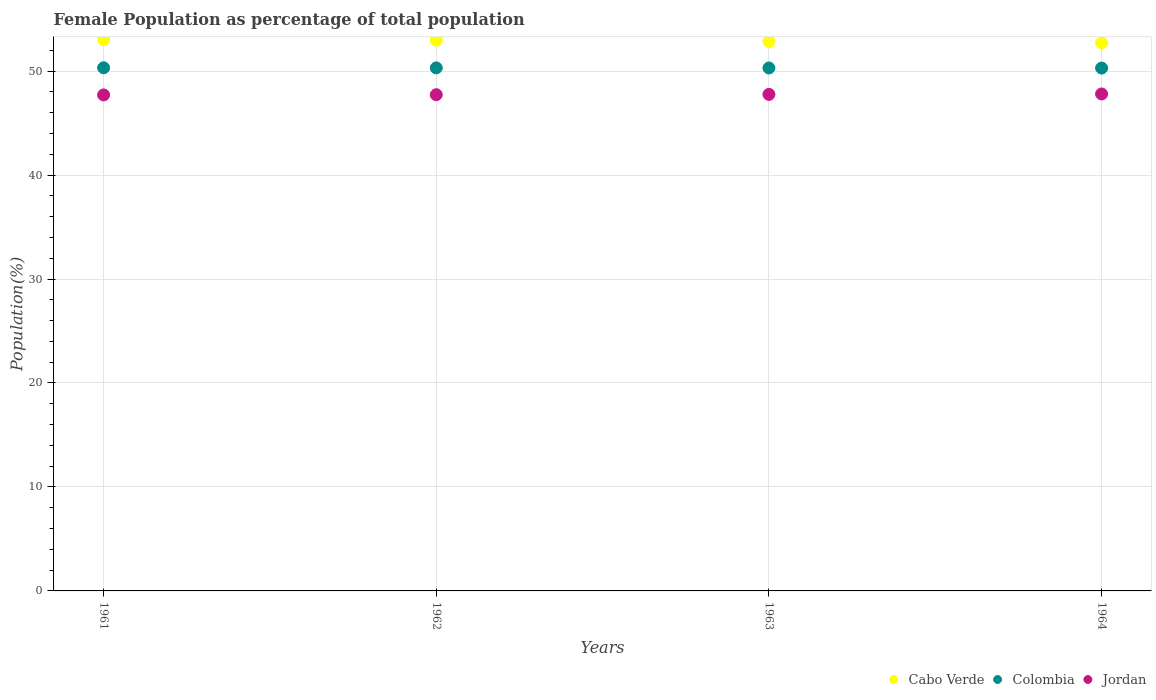How many different coloured dotlines are there?
Your answer should be very brief. 3. What is the female population in in Jordan in 1962?
Your answer should be very brief. 47.73. Across all years, what is the maximum female population in in Colombia?
Your answer should be compact. 50.32. Across all years, what is the minimum female population in in Jordan?
Give a very brief answer. 47.71. In which year was the female population in in Jordan maximum?
Ensure brevity in your answer.  1964. In which year was the female population in in Cabo Verde minimum?
Provide a short and direct response. 1964. What is the total female population in in Colombia in the graph?
Offer a very short reply. 201.22. What is the difference between the female population in in Colombia in 1963 and that in 1964?
Your answer should be very brief. 0.01. What is the difference between the female population in in Cabo Verde in 1962 and the female population in in Jordan in 1961?
Give a very brief answer. 5.26. What is the average female population in in Jordan per year?
Provide a short and direct response. 47.75. In the year 1963, what is the difference between the female population in in Jordan and female population in in Colombia?
Make the answer very short. -2.54. In how many years, is the female population in in Jordan greater than 38 %?
Make the answer very short. 4. What is the ratio of the female population in in Jordan in 1963 to that in 1964?
Your response must be concise. 1. What is the difference between the highest and the second highest female population in in Cabo Verde?
Your answer should be very brief. 0.08. What is the difference between the highest and the lowest female population in in Jordan?
Offer a very short reply. 0.09. In how many years, is the female population in in Jordan greater than the average female population in in Jordan taken over all years?
Your answer should be very brief. 2. Is the sum of the female population in in Cabo Verde in 1961 and 1964 greater than the maximum female population in in Colombia across all years?
Your response must be concise. Yes. Is it the case that in every year, the sum of the female population in in Cabo Verde and female population in in Colombia  is greater than the female population in in Jordan?
Provide a short and direct response. Yes. Does the female population in in Colombia monotonically increase over the years?
Offer a terse response. No. Is the female population in in Jordan strictly greater than the female population in in Cabo Verde over the years?
Offer a terse response. No. How many dotlines are there?
Provide a short and direct response. 3. How many years are there in the graph?
Make the answer very short. 4. Are the values on the major ticks of Y-axis written in scientific E-notation?
Provide a succinct answer. No. Does the graph contain any zero values?
Keep it short and to the point. No. How many legend labels are there?
Offer a very short reply. 3. How are the legend labels stacked?
Make the answer very short. Horizontal. What is the title of the graph?
Your answer should be compact. Female Population as percentage of total population. What is the label or title of the X-axis?
Ensure brevity in your answer.  Years. What is the label or title of the Y-axis?
Give a very brief answer. Population(%). What is the Population(%) in Cabo Verde in 1961?
Your answer should be compact. 53.05. What is the Population(%) of Colombia in 1961?
Give a very brief answer. 50.32. What is the Population(%) of Jordan in 1961?
Your answer should be compact. 47.71. What is the Population(%) of Cabo Verde in 1962?
Ensure brevity in your answer.  52.97. What is the Population(%) of Colombia in 1962?
Your response must be concise. 50.31. What is the Population(%) in Jordan in 1962?
Offer a very short reply. 47.73. What is the Population(%) of Cabo Verde in 1963?
Ensure brevity in your answer.  52.85. What is the Population(%) of Colombia in 1963?
Ensure brevity in your answer.  50.3. What is the Population(%) of Jordan in 1963?
Give a very brief answer. 47.76. What is the Population(%) of Cabo Verde in 1964?
Provide a succinct answer. 52.72. What is the Population(%) of Colombia in 1964?
Your answer should be compact. 50.29. What is the Population(%) of Jordan in 1964?
Make the answer very short. 47.8. Across all years, what is the maximum Population(%) in Cabo Verde?
Your answer should be compact. 53.05. Across all years, what is the maximum Population(%) of Colombia?
Give a very brief answer. 50.32. Across all years, what is the maximum Population(%) in Jordan?
Your response must be concise. 47.8. Across all years, what is the minimum Population(%) of Cabo Verde?
Ensure brevity in your answer.  52.72. Across all years, what is the minimum Population(%) of Colombia?
Offer a very short reply. 50.29. Across all years, what is the minimum Population(%) of Jordan?
Ensure brevity in your answer.  47.71. What is the total Population(%) in Cabo Verde in the graph?
Your answer should be very brief. 211.6. What is the total Population(%) in Colombia in the graph?
Your response must be concise. 201.22. What is the total Population(%) in Jordan in the graph?
Provide a succinct answer. 191.01. What is the difference between the Population(%) of Cabo Verde in 1961 and that in 1962?
Keep it short and to the point. 0.08. What is the difference between the Population(%) in Colombia in 1961 and that in 1962?
Your response must be concise. 0.01. What is the difference between the Population(%) of Jordan in 1961 and that in 1962?
Offer a very short reply. -0.02. What is the difference between the Population(%) of Cabo Verde in 1961 and that in 1963?
Offer a very short reply. 0.2. What is the difference between the Population(%) in Colombia in 1961 and that in 1963?
Provide a short and direct response. 0.02. What is the difference between the Population(%) in Jordan in 1961 and that in 1963?
Your response must be concise. -0.05. What is the difference between the Population(%) of Cabo Verde in 1961 and that in 1964?
Your answer should be compact. 0.33. What is the difference between the Population(%) in Colombia in 1961 and that in 1964?
Keep it short and to the point. 0.03. What is the difference between the Population(%) of Jordan in 1961 and that in 1964?
Keep it short and to the point. -0.09. What is the difference between the Population(%) of Cabo Verde in 1962 and that in 1963?
Provide a short and direct response. 0.12. What is the difference between the Population(%) in Colombia in 1962 and that in 1963?
Your answer should be very brief. 0.01. What is the difference between the Population(%) in Jordan in 1962 and that in 1963?
Offer a very short reply. -0.03. What is the difference between the Population(%) of Cabo Verde in 1962 and that in 1964?
Provide a succinct answer. 0.26. What is the difference between the Population(%) of Colombia in 1962 and that in 1964?
Make the answer very short. 0.02. What is the difference between the Population(%) of Jordan in 1962 and that in 1964?
Give a very brief answer. -0.07. What is the difference between the Population(%) in Cabo Verde in 1963 and that in 1964?
Make the answer very short. 0.13. What is the difference between the Population(%) in Colombia in 1963 and that in 1964?
Ensure brevity in your answer.  0.01. What is the difference between the Population(%) of Jordan in 1963 and that in 1964?
Offer a terse response. -0.04. What is the difference between the Population(%) in Cabo Verde in 1961 and the Population(%) in Colombia in 1962?
Your answer should be very brief. 2.74. What is the difference between the Population(%) in Cabo Verde in 1961 and the Population(%) in Jordan in 1962?
Your answer should be very brief. 5.32. What is the difference between the Population(%) in Colombia in 1961 and the Population(%) in Jordan in 1962?
Your response must be concise. 2.59. What is the difference between the Population(%) in Cabo Verde in 1961 and the Population(%) in Colombia in 1963?
Your answer should be compact. 2.75. What is the difference between the Population(%) in Cabo Verde in 1961 and the Population(%) in Jordan in 1963?
Make the answer very short. 5.29. What is the difference between the Population(%) of Colombia in 1961 and the Population(%) of Jordan in 1963?
Offer a terse response. 2.56. What is the difference between the Population(%) in Cabo Verde in 1961 and the Population(%) in Colombia in 1964?
Offer a terse response. 2.76. What is the difference between the Population(%) in Cabo Verde in 1961 and the Population(%) in Jordan in 1964?
Make the answer very short. 5.25. What is the difference between the Population(%) in Colombia in 1961 and the Population(%) in Jordan in 1964?
Your answer should be compact. 2.51. What is the difference between the Population(%) of Cabo Verde in 1962 and the Population(%) of Colombia in 1963?
Ensure brevity in your answer.  2.67. What is the difference between the Population(%) of Cabo Verde in 1962 and the Population(%) of Jordan in 1963?
Give a very brief answer. 5.21. What is the difference between the Population(%) in Colombia in 1962 and the Population(%) in Jordan in 1963?
Ensure brevity in your answer.  2.55. What is the difference between the Population(%) in Cabo Verde in 1962 and the Population(%) in Colombia in 1964?
Your answer should be very brief. 2.68. What is the difference between the Population(%) of Cabo Verde in 1962 and the Population(%) of Jordan in 1964?
Provide a succinct answer. 5.17. What is the difference between the Population(%) in Colombia in 1962 and the Population(%) in Jordan in 1964?
Your response must be concise. 2.51. What is the difference between the Population(%) of Cabo Verde in 1963 and the Population(%) of Colombia in 1964?
Provide a succinct answer. 2.56. What is the difference between the Population(%) of Cabo Verde in 1963 and the Population(%) of Jordan in 1964?
Offer a very short reply. 5.05. What is the difference between the Population(%) of Colombia in 1963 and the Population(%) of Jordan in 1964?
Your answer should be compact. 2.5. What is the average Population(%) of Cabo Verde per year?
Offer a terse response. 52.9. What is the average Population(%) in Colombia per year?
Offer a terse response. 50.31. What is the average Population(%) in Jordan per year?
Make the answer very short. 47.75. In the year 1961, what is the difference between the Population(%) of Cabo Verde and Population(%) of Colombia?
Your response must be concise. 2.74. In the year 1961, what is the difference between the Population(%) of Cabo Verde and Population(%) of Jordan?
Make the answer very short. 5.34. In the year 1961, what is the difference between the Population(%) of Colombia and Population(%) of Jordan?
Your answer should be very brief. 2.61. In the year 1962, what is the difference between the Population(%) in Cabo Verde and Population(%) in Colombia?
Provide a short and direct response. 2.66. In the year 1962, what is the difference between the Population(%) in Cabo Verde and Population(%) in Jordan?
Your answer should be very brief. 5.24. In the year 1962, what is the difference between the Population(%) of Colombia and Population(%) of Jordan?
Your response must be concise. 2.58. In the year 1963, what is the difference between the Population(%) of Cabo Verde and Population(%) of Colombia?
Offer a very short reply. 2.55. In the year 1963, what is the difference between the Population(%) in Cabo Verde and Population(%) in Jordan?
Ensure brevity in your answer.  5.09. In the year 1963, what is the difference between the Population(%) in Colombia and Population(%) in Jordan?
Give a very brief answer. 2.54. In the year 1964, what is the difference between the Population(%) in Cabo Verde and Population(%) in Colombia?
Provide a short and direct response. 2.43. In the year 1964, what is the difference between the Population(%) in Cabo Verde and Population(%) in Jordan?
Make the answer very short. 4.92. In the year 1964, what is the difference between the Population(%) in Colombia and Population(%) in Jordan?
Offer a terse response. 2.49. What is the ratio of the Population(%) in Cabo Verde in 1961 to that in 1962?
Provide a succinct answer. 1. What is the ratio of the Population(%) of Jordan in 1961 to that in 1962?
Provide a short and direct response. 1. What is the ratio of the Population(%) in Cabo Verde in 1961 to that in 1963?
Your answer should be compact. 1. What is the ratio of the Population(%) of Cabo Verde in 1961 to that in 1964?
Make the answer very short. 1.01. What is the ratio of the Population(%) of Colombia in 1962 to that in 1963?
Ensure brevity in your answer.  1. What is the ratio of the Population(%) in Cabo Verde in 1962 to that in 1964?
Ensure brevity in your answer.  1. What is the ratio of the Population(%) of Cabo Verde in 1963 to that in 1964?
Keep it short and to the point. 1. What is the ratio of the Population(%) of Jordan in 1963 to that in 1964?
Provide a succinct answer. 1. What is the difference between the highest and the second highest Population(%) in Cabo Verde?
Give a very brief answer. 0.08. What is the difference between the highest and the second highest Population(%) in Colombia?
Your response must be concise. 0.01. What is the difference between the highest and the second highest Population(%) in Jordan?
Your answer should be very brief. 0.04. What is the difference between the highest and the lowest Population(%) of Cabo Verde?
Offer a very short reply. 0.33. What is the difference between the highest and the lowest Population(%) in Colombia?
Provide a succinct answer. 0.03. What is the difference between the highest and the lowest Population(%) in Jordan?
Provide a short and direct response. 0.09. 